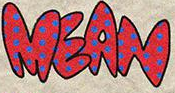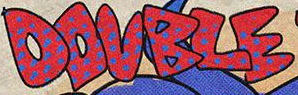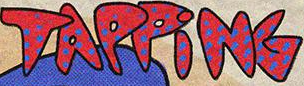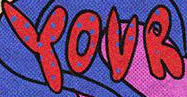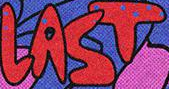Read the text content from these images in order, separated by a semicolon. MEAN; DOUBLE; TAPPiNG; YOUR; LAST 